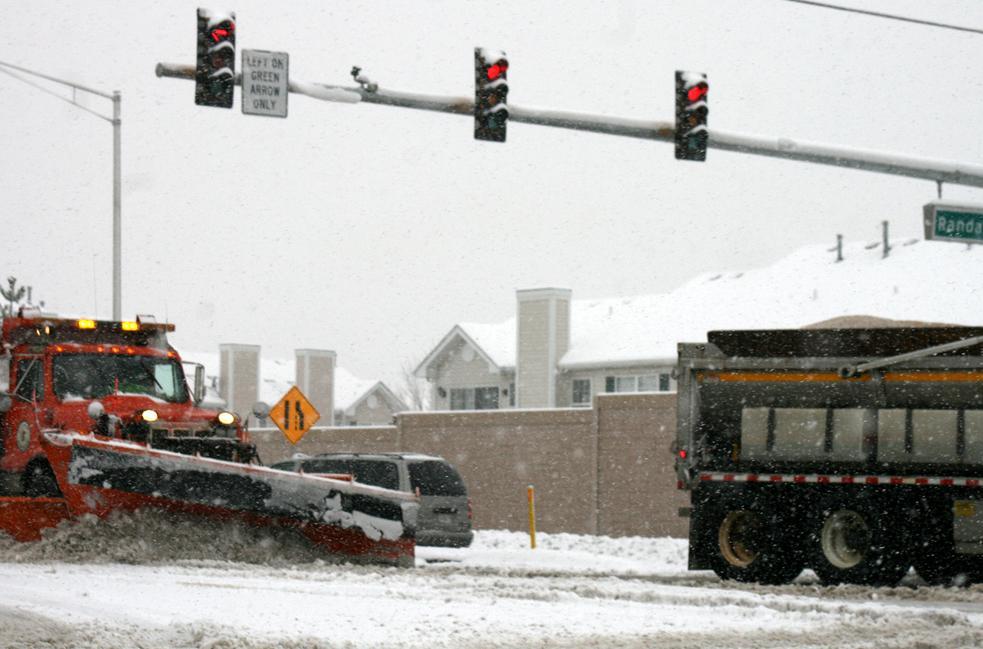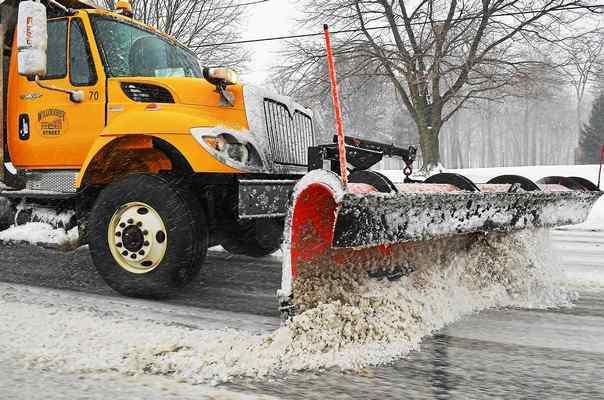The first image is the image on the left, the second image is the image on the right. Assess this claim about the two images: "There is a white vehicle.". Correct or not? Answer yes or no. No. 